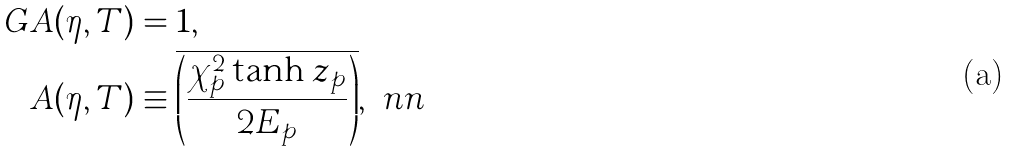<formula> <loc_0><loc_0><loc_500><loc_500>G A ( \eta , T ) & = 1 , \\ A ( \eta , T ) & \equiv \overline { \left ( \frac { \chi _ { p } ^ { 2 } \tanh z _ { p } } { 2 E _ { p } } \right ) } , \ n n</formula> 